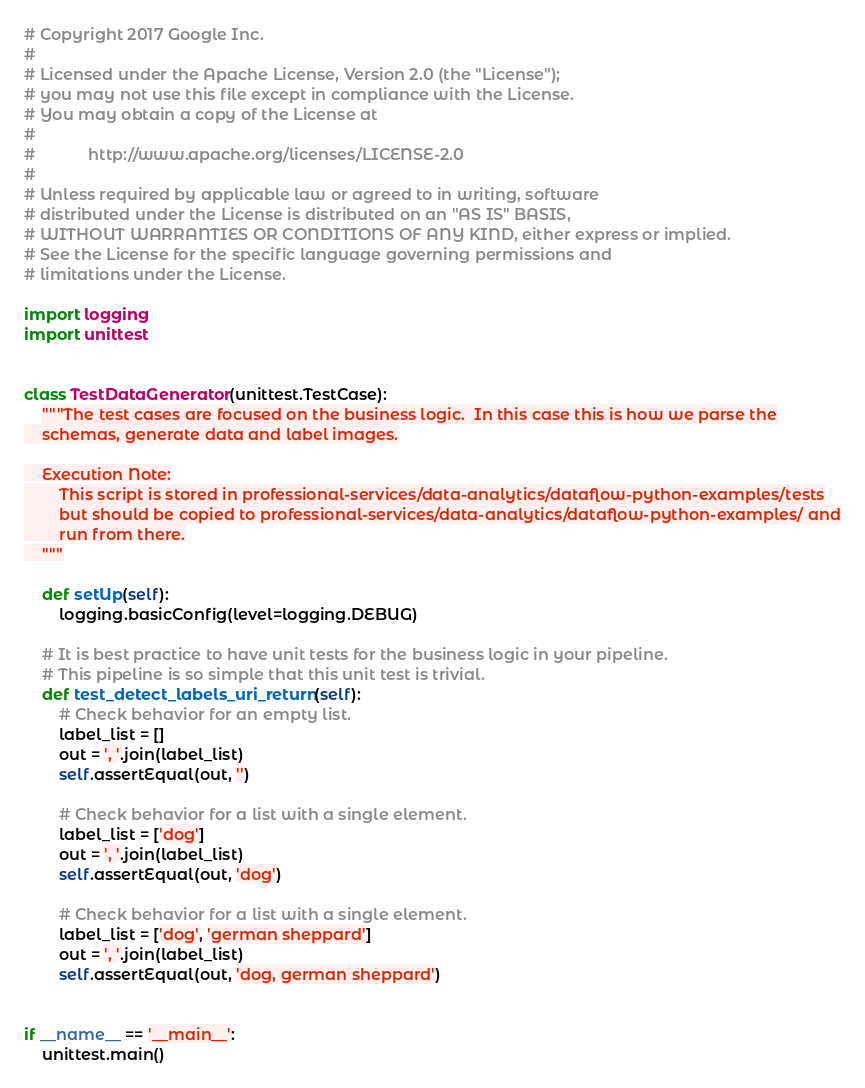<code> <loc_0><loc_0><loc_500><loc_500><_Python_># Copyright 2017 Google Inc.
#
# Licensed under the Apache License, Version 2.0 (the "License");
# you may not use this file except in compliance with the License.
# You may obtain a copy of the License at
#
#            http://www.apache.org/licenses/LICENSE-2.0
#
# Unless required by applicable law or agreed to in writing, software
# distributed under the License is distributed on an "AS IS" BASIS,
# WITHOUT WARRANTIES OR CONDITIONS OF ANY KIND, either express or implied.
# See the License for the specific language governing permissions and
# limitations under the License.

import logging
import unittest


class TestDataGenerator(unittest.TestCase):
    """The test cases are focused on the business logic.  In this case this is how we parse the
    schemas, generate data and label images.

    Execution Note:
        This script is stored in professional-services/data-analytics/dataflow-python-examples/tests
        but should be copied to professional-services/data-analytics/dataflow-python-examples/ and
        run from there.
    """

    def setUp(self):
        logging.basicConfig(level=logging.DEBUG)

    # It is best practice to have unit tests for the business logic in your pipeline.
    # This pipeline is so simple that this unit test is trivial.
    def test_detect_labels_uri_return(self):
        # Check behavior for an empty list.
        label_list = []
        out = ', '.join(label_list)
        self.assertEqual(out, '')

        # Check behavior for a list with a single element.
        label_list = ['dog']
        out = ', '.join(label_list)
        self.assertEqual(out, 'dog')

        # Check behavior for a list with a single element.
        label_list = ['dog', 'german sheppard']
        out = ', '.join(label_list)
        self.assertEqual(out, 'dog, german sheppard')


if __name__ == '__main__':
    unittest.main()
</code> 